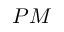Convert formula to latex. <formula><loc_0><loc_0><loc_500><loc_500>P M</formula> 